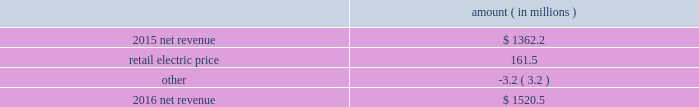Entergy arkansas , inc .
And subsidiaries management 2019s financial discussion and analysis results of operations net income 2016 compared to 2015 net income increased $ 92.9 million primarily due to higher net revenue and lower other operation and maintenance expenses , partially offset by a higher effective income tax rate and higher depreciation and amortization expenses .
2015 compared to 2014 net income decreased $ 47.1 million primarily due to higher other operation and maintenance expenses , partially offset by higher net revenue .
Net revenue 2016 compared to 2015 net revenue consists of operating revenues net of : 1 ) fuel , fuel-related expenses , and gas purchased for resale , 2 ) purchased power expenses , and 3 ) other regulatory charges ( credits ) .
Following is an analysis of the change in net revenue comparing 2016 to 2015 .
Amount ( in millions ) .
The retail electric price variance is primarily due to an increase in base rates , as approved by the apsc .
The new base rates were effective february 24 , 2016 and began billing with the first billing cycle of april 2016 .
The increase includes an interim base rate adjustment surcharge , effective with the first billing cycle of april 2016 , to recover the incremental revenue requirement for the period february 24 , 2016 through march 31 , 2016 .
A significant portion of the increase is related to the purchase of power block 2 of the union power station .
See note 2 to the financial statements for further discussion of the rate case .
See note 14 to the financial statements for further discussion of the union power station purchase. .
What is the growth rate in net revenue in 2016 for entergy arkansas , inc.? 
Computations: ((1520.5 - 1362.2) / 1362.2)
Answer: 0.11621. 